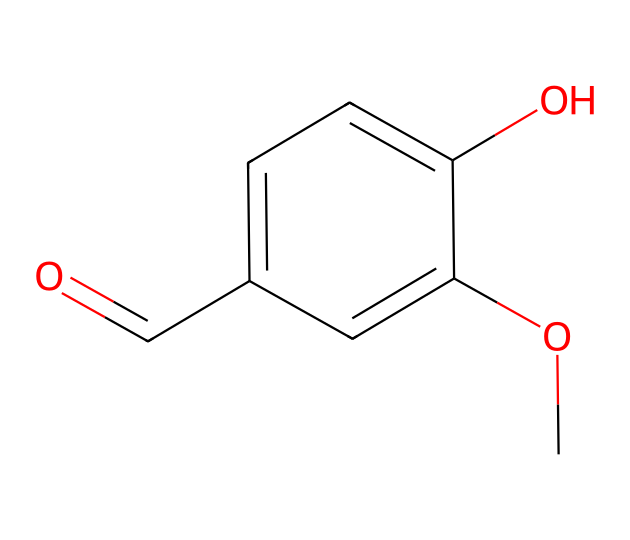What is the primary functional group present in vanillin? The functional group present in this molecule is the aldehyde group, identified by the carbonyl (C=O) connected to a hydrogen atom (H). This indicates that the compound belongs to the aldehyde class.
Answer: aldehyde How many carbon atoms are in the vanillin structure? By analyzing the SMILES representation, you can count five carbon atoms (C) in total within the molecular structure.
Answer: 5 What is the total number of oxygen atoms in vanillin? In the given structure, there are two oxygen atoms (O) indicated in the molecular representation. You see one in the carbonyl group and one in the methoxy (–OCH3) part.
Answer: 2 Does vanillin exhibit aromaticity? Yes, the presence of the benzene ring structure (indicated by 'c' in the SMILES) allows us to conclude that vanillin is aromatic. Aromatic compounds possess a cyclic structure with delocalized pi electrons.
Answer: yes What property makes vanillin a flavoring agent? The chemical structure of vanillin, particularly the aldehyde group and the attached methoxy group, contributes to its sweet flavor profile, making it effective in flavoring applications.
Answer: sweet What type of reaction can vanillin participate in due to its aldehyde group? Vanillin's aldehyde functional group can undergo oxidation reactions, commonly converting to a carboxylic acid under certain conditions, illustrating its reactivity.
Answer: oxidation 